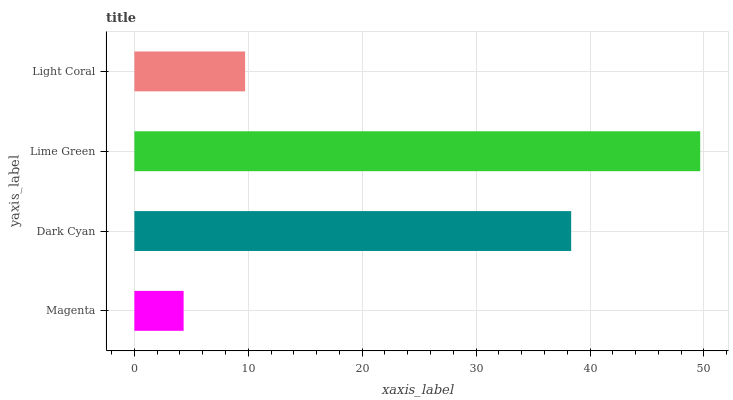Is Magenta the minimum?
Answer yes or no. Yes. Is Lime Green the maximum?
Answer yes or no. Yes. Is Dark Cyan the minimum?
Answer yes or no. No. Is Dark Cyan the maximum?
Answer yes or no. No. Is Dark Cyan greater than Magenta?
Answer yes or no. Yes. Is Magenta less than Dark Cyan?
Answer yes or no. Yes. Is Magenta greater than Dark Cyan?
Answer yes or no. No. Is Dark Cyan less than Magenta?
Answer yes or no. No. Is Dark Cyan the high median?
Answer yes or no. Yes. Is Light Coral the low median?
Answer yes or no. Yes. Is Lime Green the high median?
Answer yes or no. No. Is Lime Green the low median?
Answer yes or no. No. 